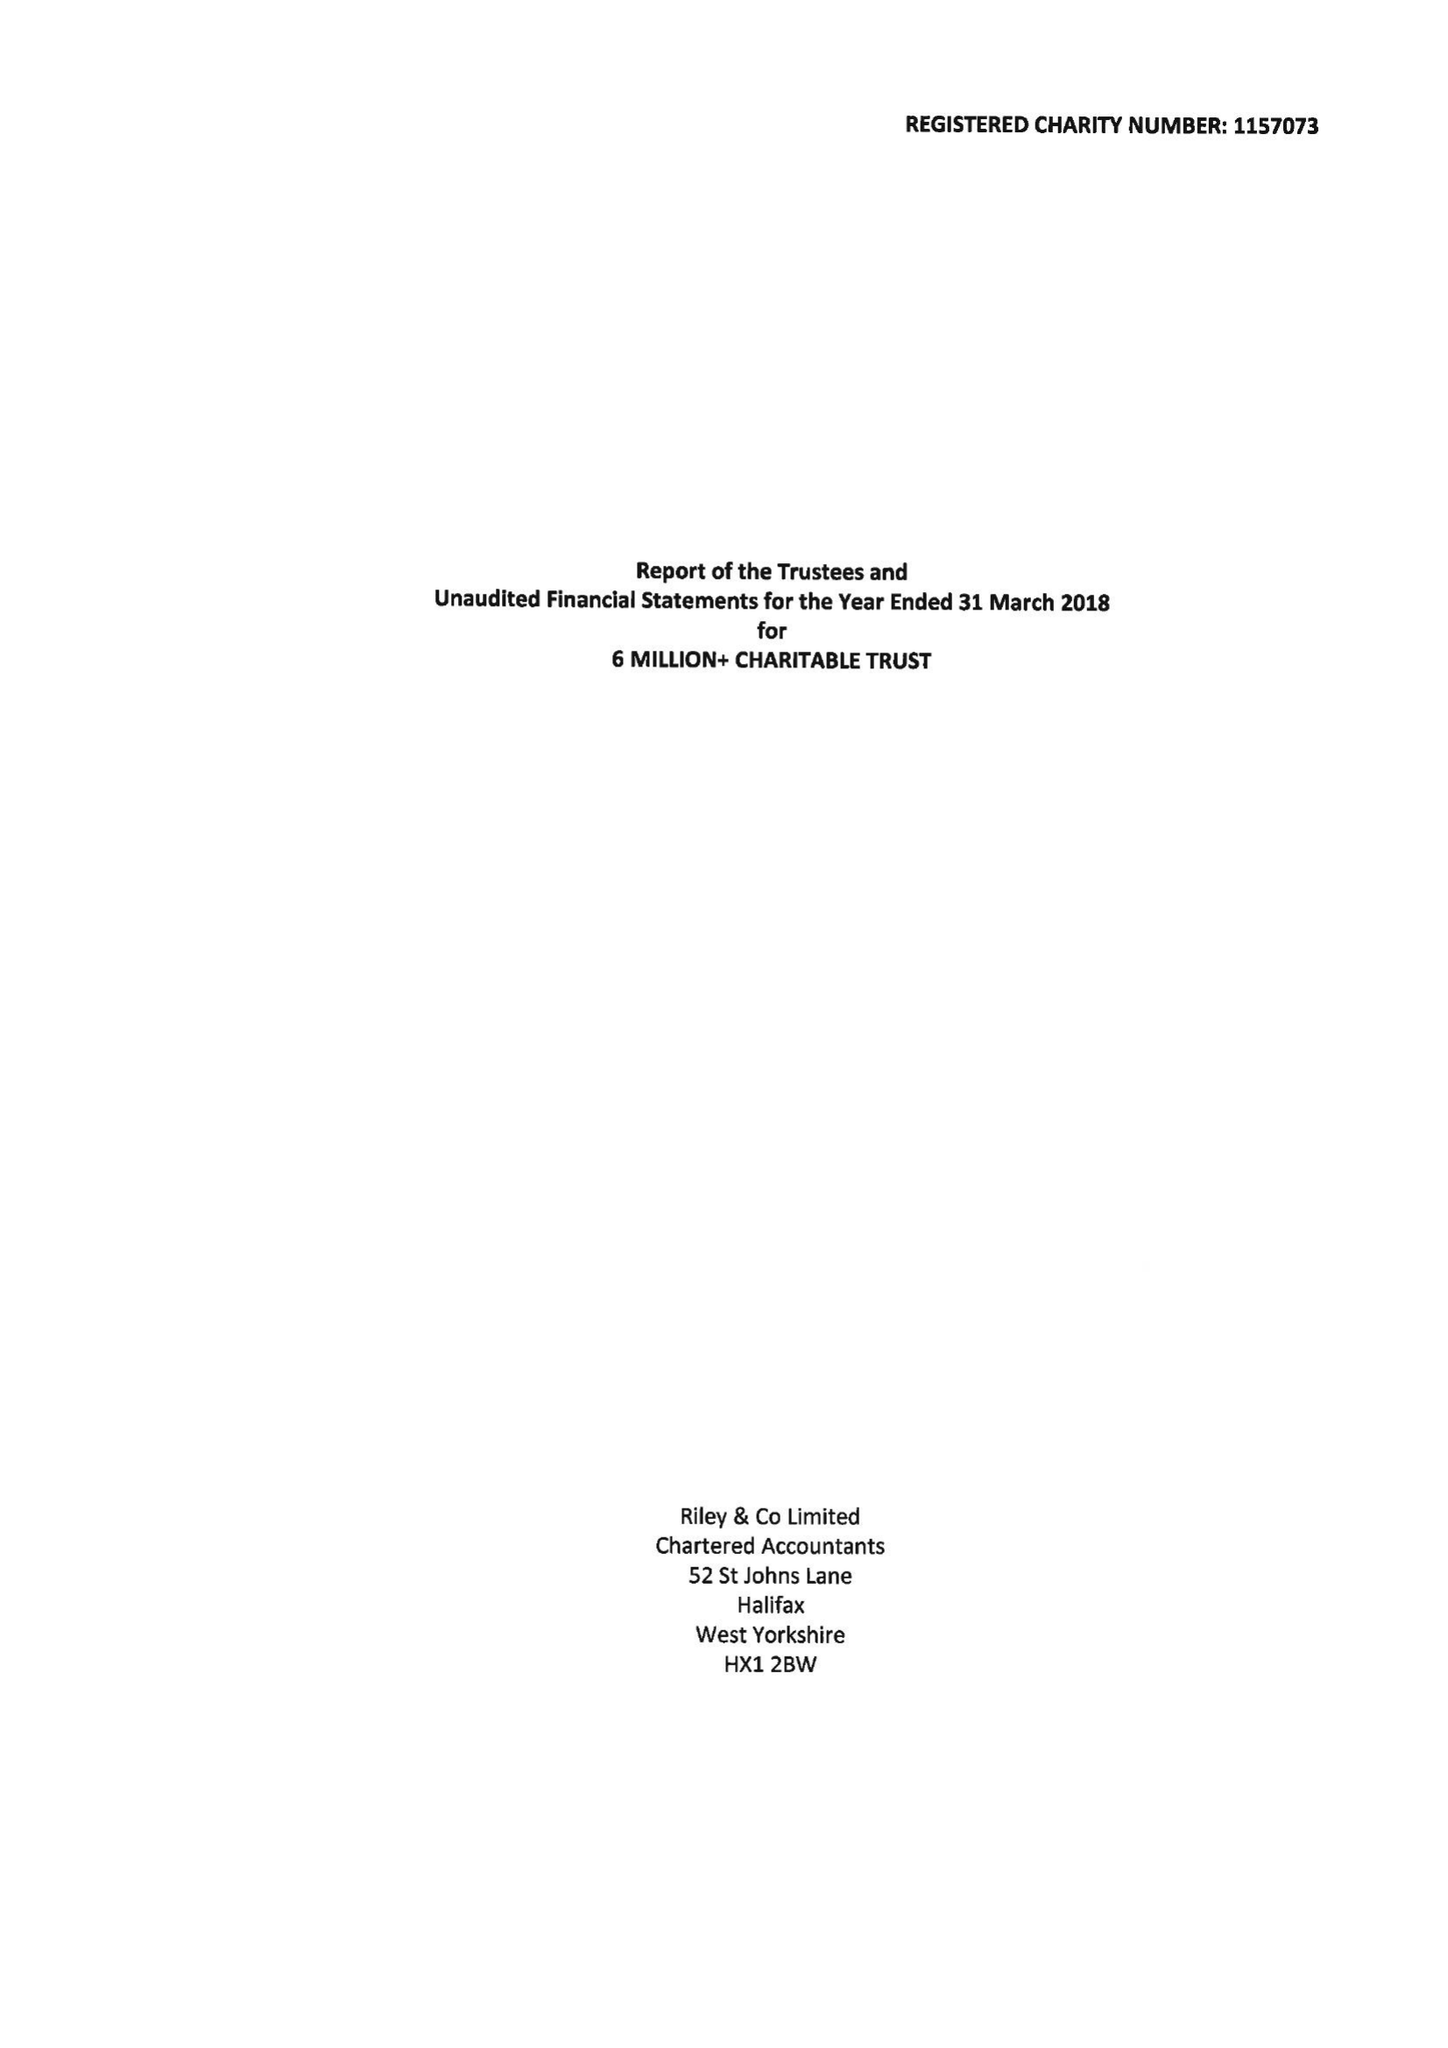What is the value for the charity_number?
Answer the question using a single word or phrase. 1157073 